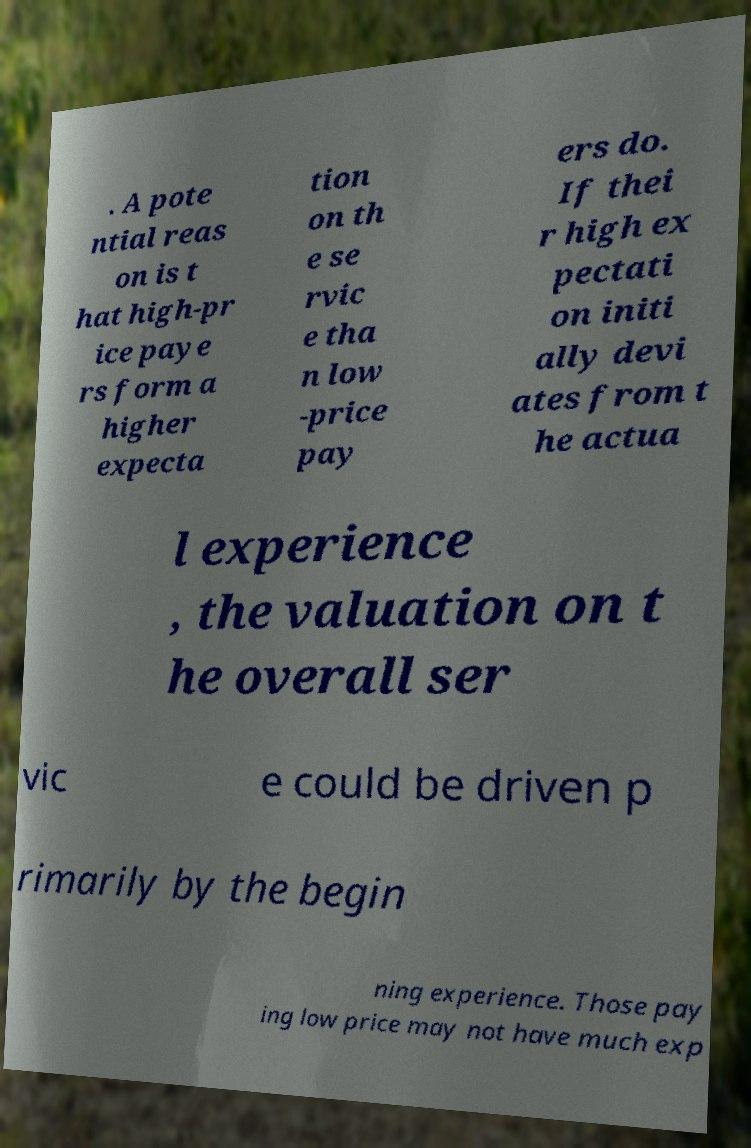There's text embedded in this image that I need extracted. Can you transcribe it verbatim? . A pote ntial reas on is t hat high-pr ice paye rs form a higher expecta tion on th e se rvic e tha n low -price pay ers do. If thei r high ex pectati on initi ally devi ates from t he actua l experience , the valuation on t he overall ser vic e could be driven p rimarily by the begin ning experience. Those pay ing low price may not have much exp 